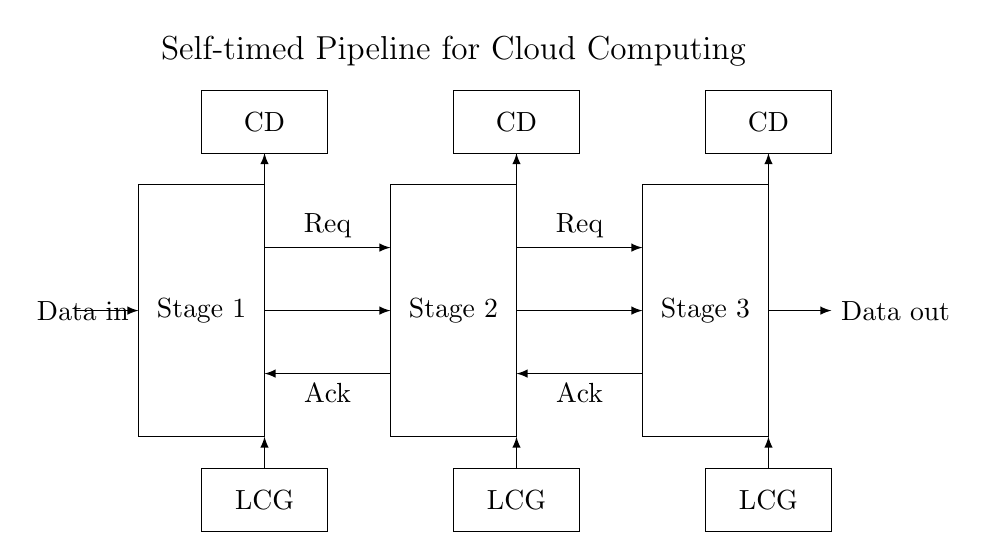What are the stages present in the pipeline? The pipeline consists of three stages labeled as Stage 1, Stage 2, and Stage 3, each represented by a rectangle in the diagram.
Answer: Stage 1, Stage 2, Stage 3 What do the arrows indicate in the data flow? The arrows labeled as "Data in" and "Data out" show the direction of data movement into and out of the pipeline stages, indicating the flow of information throughout the circuit.
Answer: Data flow direction What do the handshake signals represent? The handshake signals labeled "Req" and "Ack" represent the request and acknowledgment lines that facilitate communication between stages, ensuring that data is passed only when ready.
Answer: Request and acknowledgment signals How many local clock generators are there? There are three local clock generators, one corresponding to each stage, indicated by the rectangles labeled "LCG."
Answer: Three What is the purpose of completion detection (CD)? Completion detection blocks ensure that each stage of the pipeline only signals readiness to proceed when it has finished processing the received data, allowing for synchronized operation in the asynchronous design.
Answer: Signal stage completion What does the label "Data out" indicate? The label "Data out" indicates the final output point of data processing after it has passed through all three pipeline stages, representing the completion of data handling in the circuit.
Answer: Final output of data processing Why is this pipeline considered 'self-timed'? The pipeline is considered 'self-timed' because it uses local clock generators at each stage, allowing stages to operate independently and respond to data completion signals without a global clock, enhancing efficiency.
Answer: Independent operation of stages 